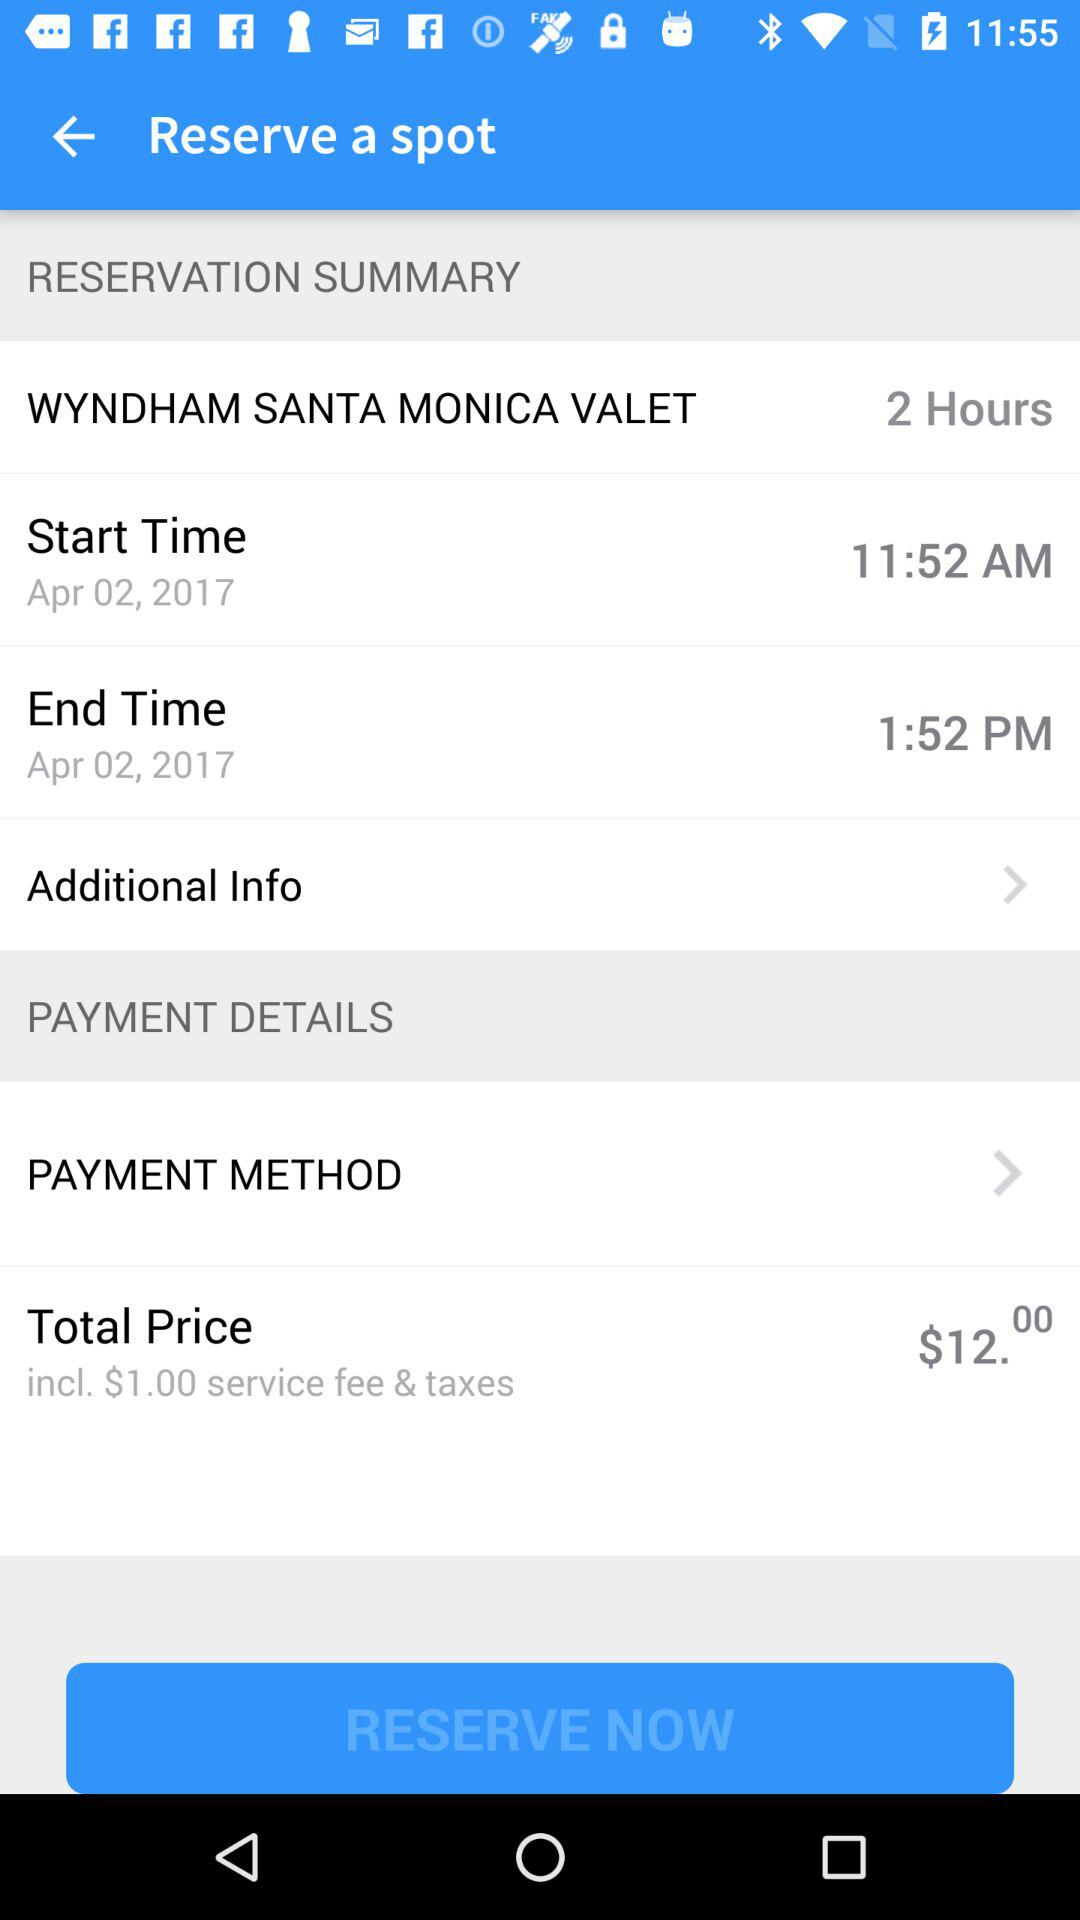What is the currency used for the total price? The used currency is dollars. 